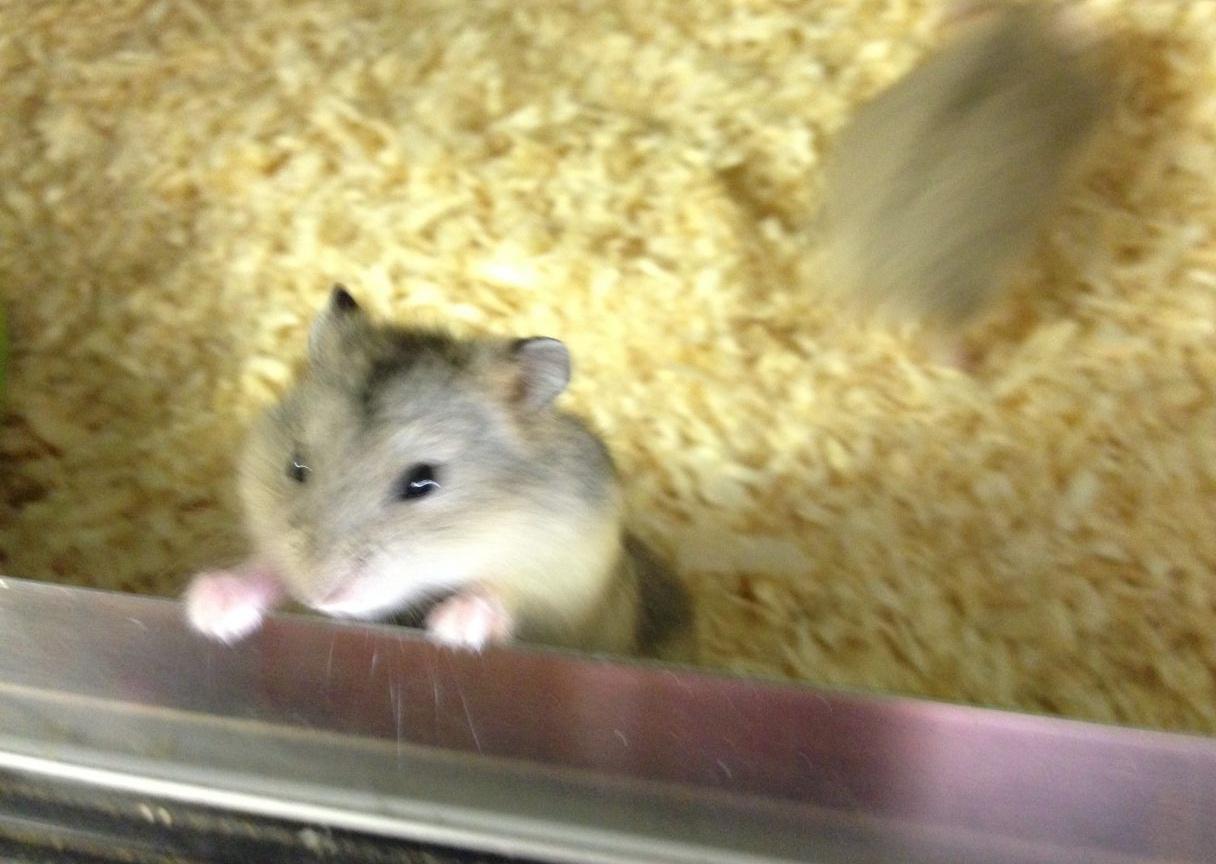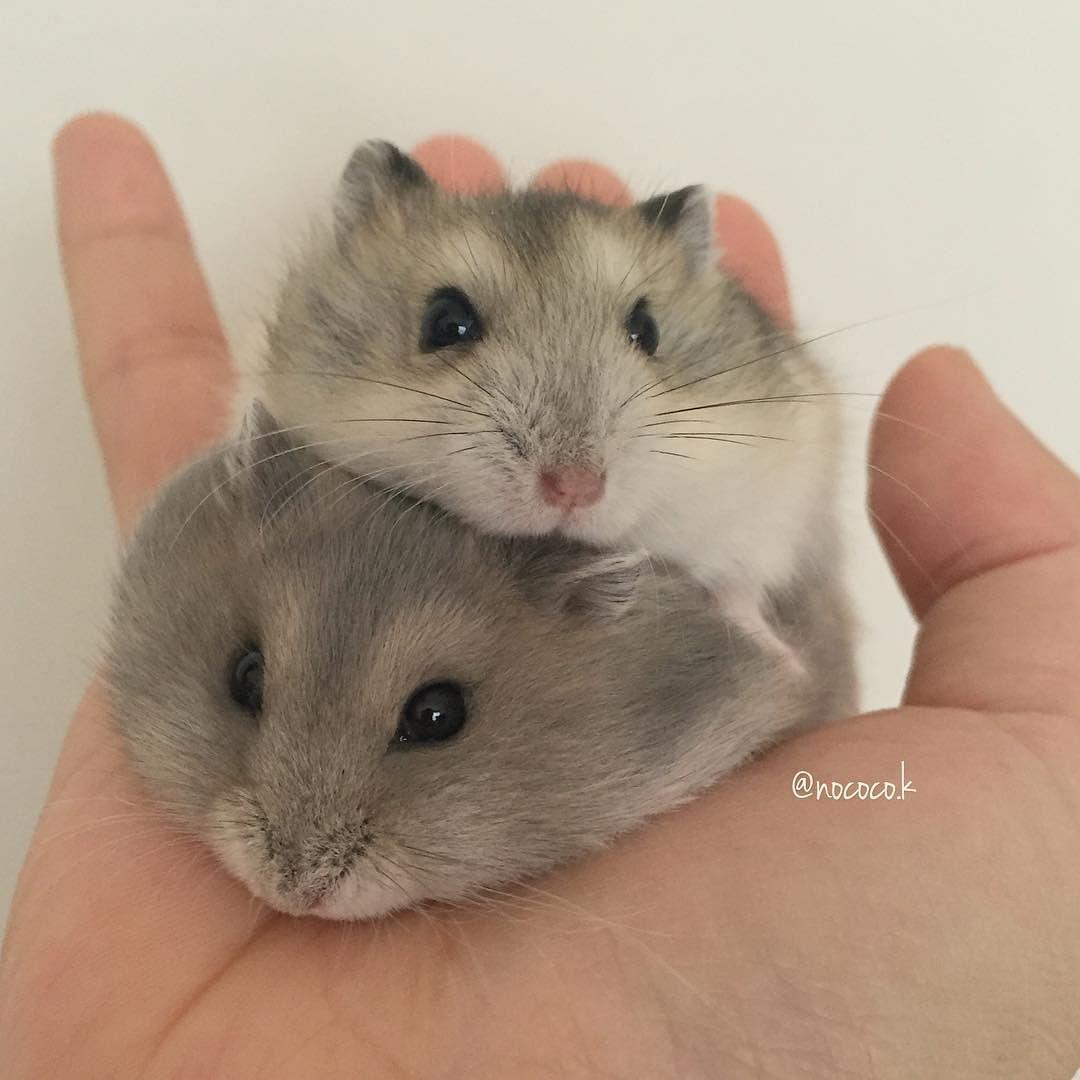The first image is the image on the left, the second image is the image on the right. Examine the images to the left and right. Is the description "Right image shows one pet rodent posed with both front paws off the ground in front of its chest." accurate? Answer yes or no. No. The first image is the image on the left, the second image is the image on the right. For the images displayed, is the sentence "One of the images features some of the hamster's food." factually correct? Answer yes or no. No. 